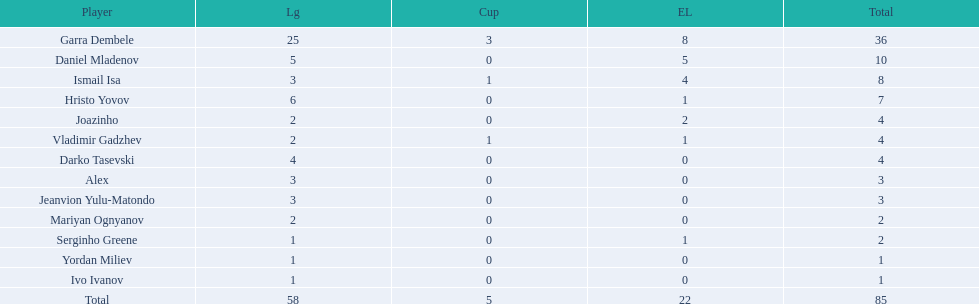How many players had a total of 4? 3. 